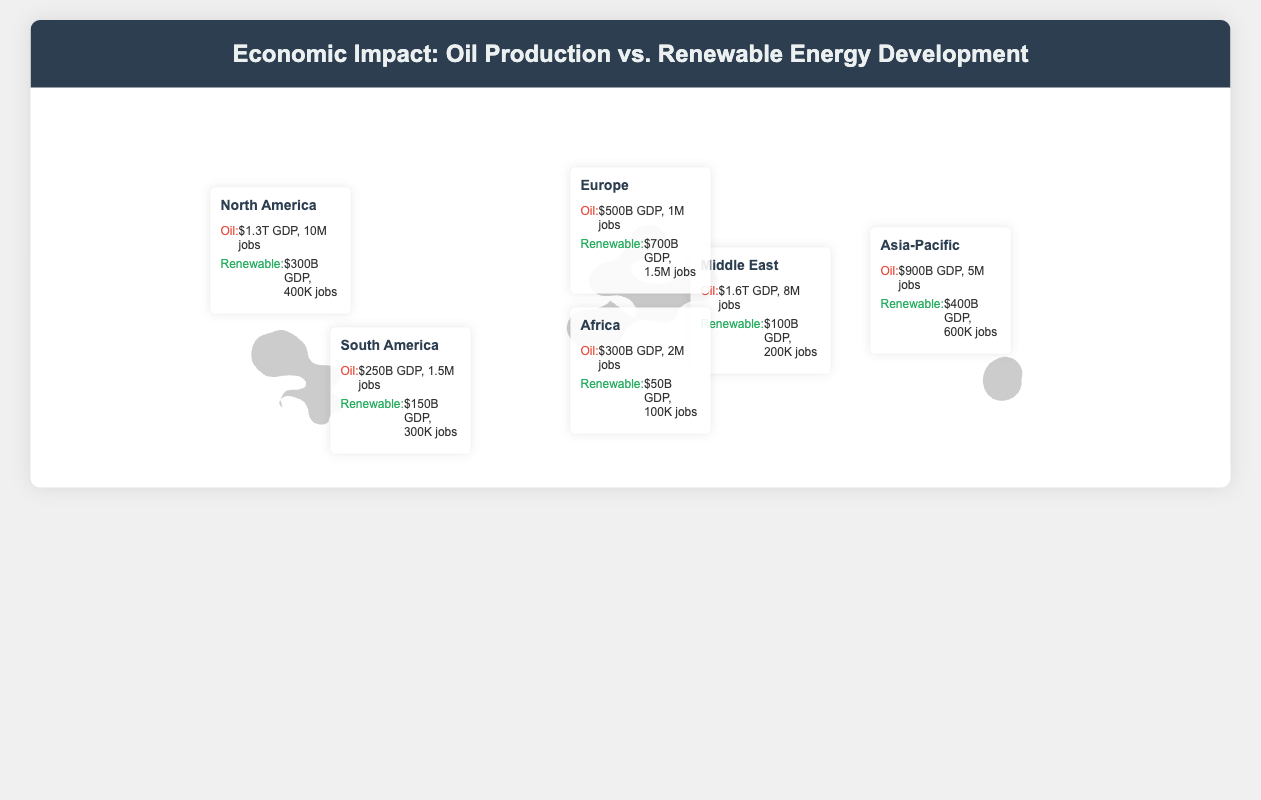What is the GDP contribution of oil production in North America? The GDP contribution from oil production in North America is stated as $1.3T.
Answer: $1.3T What is the number of jobs generated by renewable energy in Europe? The document states that renewable energy in Europe generates 1.5M jobs.
Answer: 1.5M jobs Which region has the highest GDP from oil production? The Middle East has the highest GDP from oil production at $1.6T.
Answer: $1.6T What is the total GDP contribution from renewable energy in Asia-Pacific and Africa? The GDP from renewable energy in Asia-Pacific is $400B and in Africa is $50B, totaling $450B.
Answer: $450B How many jobs are generated by oil production in South America? The document indicates that oil production in South America generates 1.5M jobs.
Answer: 1.5M jobs Which region has a higher GDP from renewable energy, Europe or North America? The document states Europe has $700B and North America has $300B from renewable energy, thus Europe has a higher GDP.
Answer: Europe What is the oil production GDP in Africa? The GDP from oil production in Africa is $300B.
Answer: $300B How many jobs does renewable energy create in the Middle East? The number of jobs created by renewable energy in the Middle East is reported as 200K.
Answer: 200K Which region has the lowest contribution to GDP from renewable energy? Africa has the lowest contribution to GDP from renewable energy at $50B.
Answer: $50B 